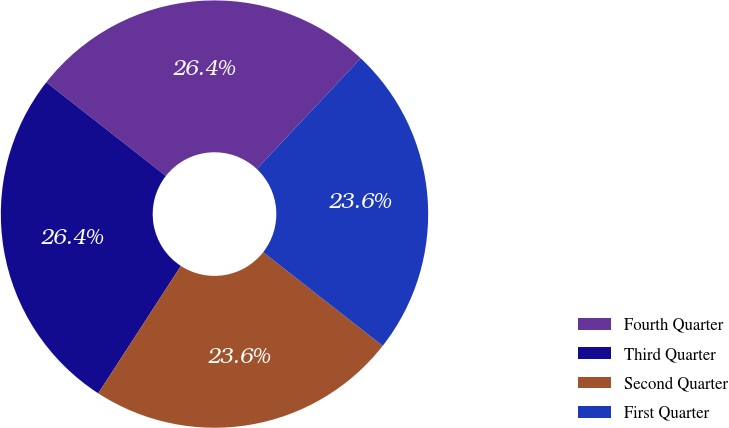Convert chart to OTSL. <chart><loc_0><loc_0><loc_500><loc_500><pie_chart><fcel>Fourth Quarter<fcel>Third Quarter<fcel>Second Quarter<fcel>First Quarter<nl><fcel>26.42%<fcel>26.42%<fcel>23.58%<fcel>23.58%<nl></chart> 